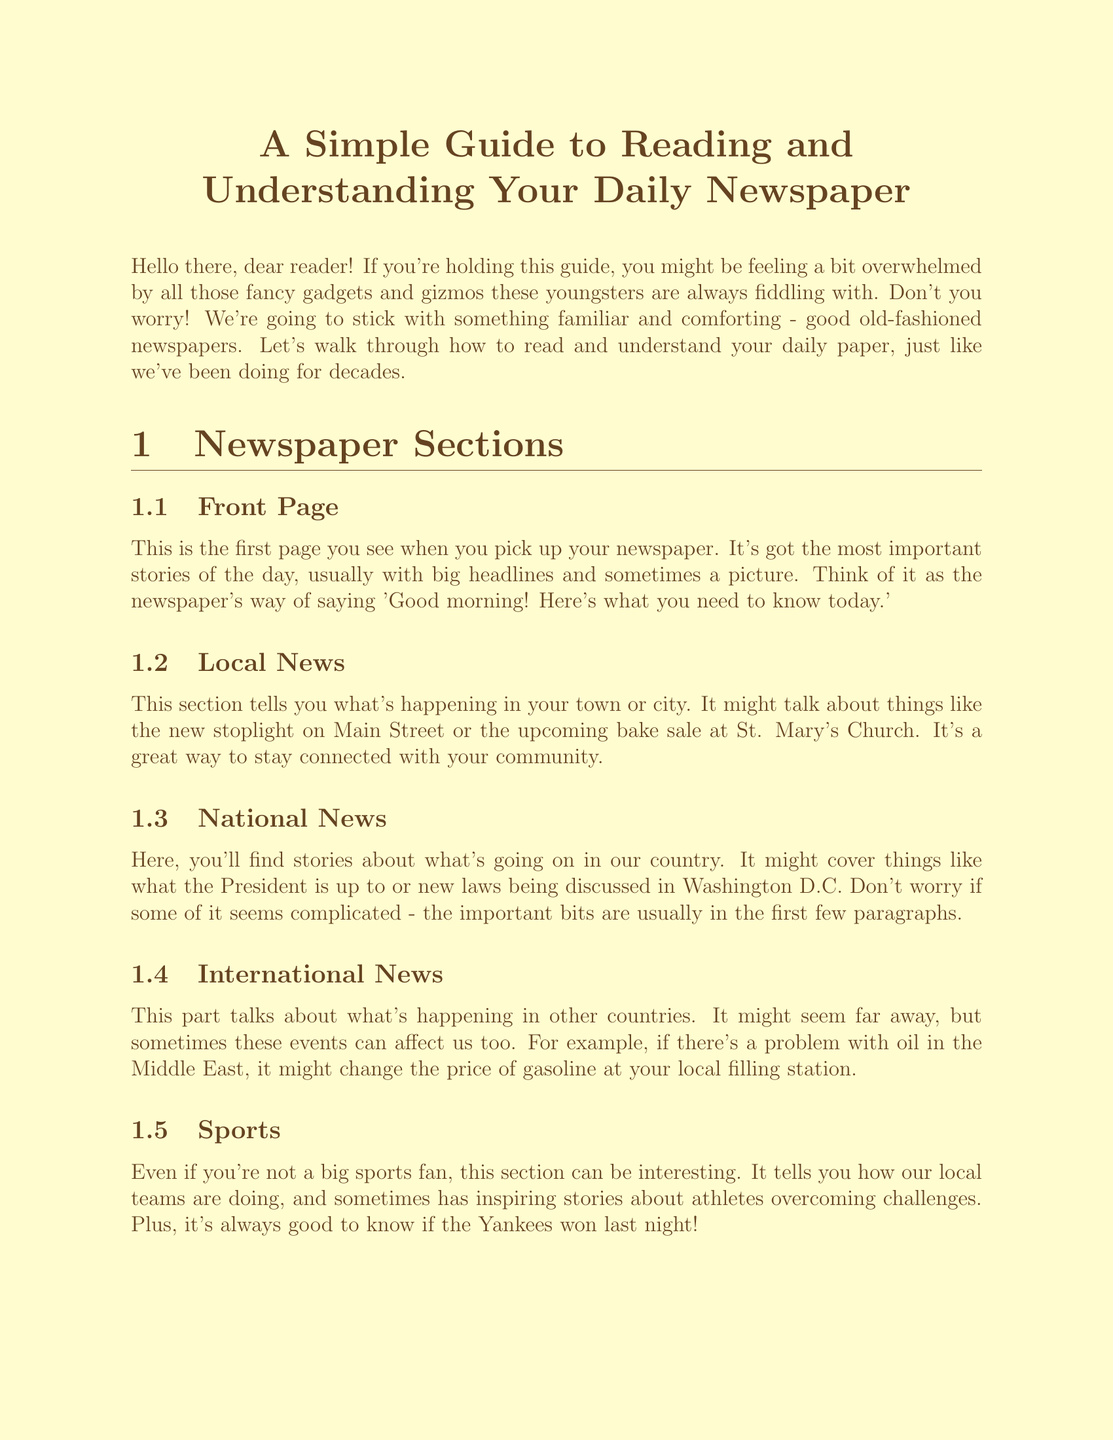What is the title of the guide? The title is stated at the beginning of the document, introducing the content.
Answer: A Simple Guide to Reading and Understanding Your Daily Newspaper What section discusses community events? This information is in the Local News section, which specifically talks about happenings in the community.
Answer: Local News What is a byline? The document defines a byline as the name of the person who wrote the article.
Answer: Name of the person who wrote the article What is usually found on the front page? The front page contains the most important stories of the day.
Answer: The most important stories of the day What type of article expresses the newspaper's opinion? The document mentions an editorial as the type of article where the newspaper shares its opinion.
Answer: Editorial What does "above the fold" refer to? It refers to the top half of the front page of the newspaper.
Answer: The top half of the front page How many sections are listed in the document? The total sections listed provide a clear overview of the content of the newspaper.
Answer: Seven What tip is given for reading the newspaper comfortably? A specific suggestion is made to take breaks or use tools to help with reading.
Answer: Use a magnifying glass 